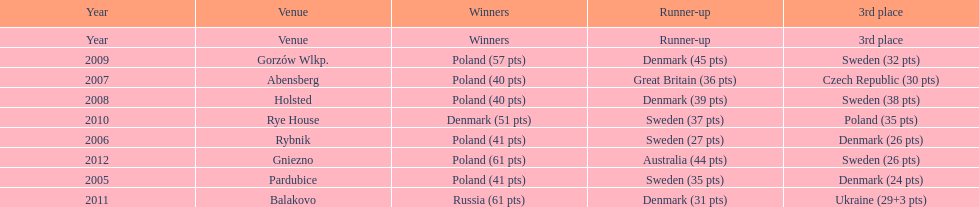When was the first year that poland did not place in the top three positions of the team speedway junior world championship? 2011. 